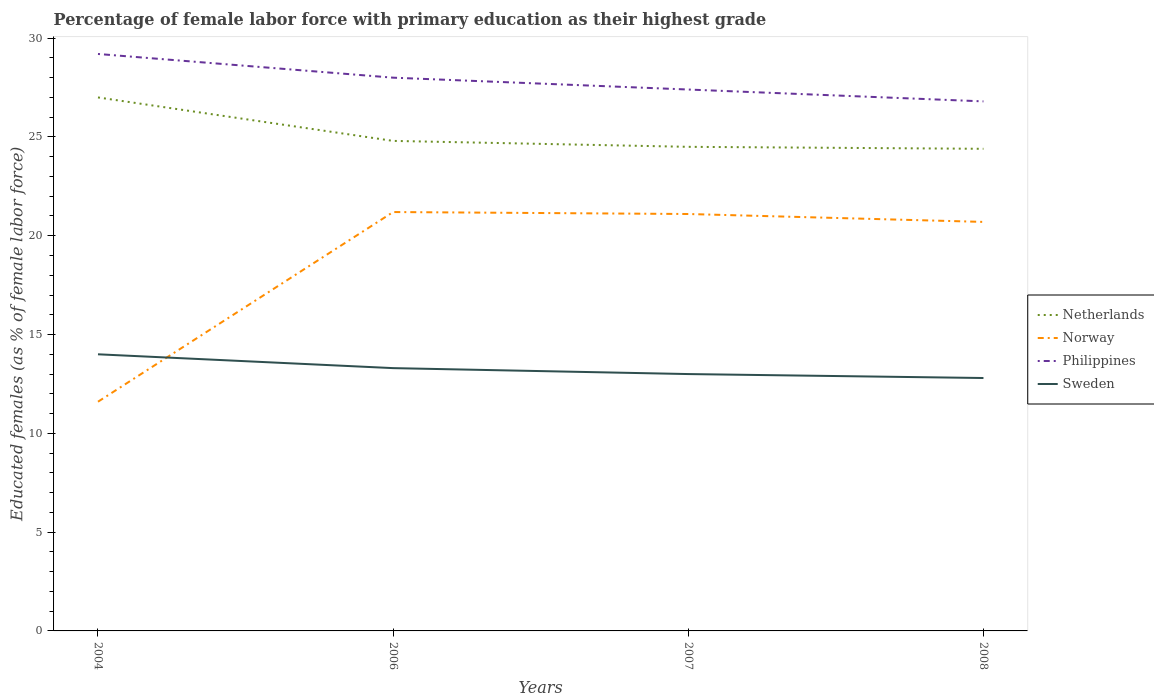Does the line corresponding to Philippines intersect with the line corresponding to Norway?
Offer a very short reply. No. Across all years, what is the maximum percentage of female labor force with primary education in Netherlands?
Provide a succinct answer. 24.4. What is the total percentage of female labor force with primary education in Netherlands in the graph?
Your response must be concise. 2.2. What is the difference between the highest and the second highest percentage of female labor force with primary education in Netherlands?
Offer a very short reply. 2.6. What is the difference between the highest and the lowest percentage of female labor force with primary education in Philippines?
Your answer should be compact. 2. What is the difference between two consecutive major ticks on the Y-axis?
Offer a very short reply. 5. Does the graph contain grids?
Make the answer very short. No. How many legend labels are there?
Your response must be concise. 4. What is the title of the graph?
Offer a very short reply. Percentage of female labor force with primary education as their highest grade. Does "Solomon Islands" appear as one of the legend labels in the graph?
Provide a succinct answer. No. What is the label or title of the Y-axis?
Make the answer very short. Educated females (as % of female labor force). What is the Educated females (as % of female labor force) of Norway in 2004?
Your answer should be compact. 11.6. What is the Educated females (as % of female labor force) in Philippines in 2004?
Offer a very short reply. 29.2. What is the Educated females (as % of female labor force) in Netherlands in 2006?
Offer a terse response. 24.8. What is the Educated females (as % of female labor force) in Norway in 2006?
Give a very brief answer. 21.2. What is the Educated females (as % of female labor force) of Sweden in 2006?
Keep it short and to the point. 13.3. What is the Educated females (as % of female labor force) in Netherlands in 2007?
Ensure brevity in your answer.  24.5. What is the Educated females (as % of female labor force) of Norway in 2007?
Provide a short and direct response. 21.1. What is the Educated females (as % of female labor force) of Philippines in 2007?
Your answer should be very brief. 27.4. What is the Educated females (as % of female labor force) of Sweden in 2007?
Your answer should be compact. 13. What is the Educated females (as % of female labor force) of Netherlands in 2008?
Provide a succinct answer. 24.4. What is the Educated females (as % of female labor force) of Norway in 2008?
Your response must be concise. 20.7. What is the Educated females (as % of female labor force) of Philippines in 2008?
Provide a succinct answer. 26.8. What is the Educated females (as % of female labor force) in Sweden in 2008?
Provide a succinct answer. 12.8. Across all years, what is the maximum Educated females (as % of female labor force) of Norway?
Offer a very short reply. 21.2. Across all years, what is the maximum Educated females (as % of female labor force) in Philippines?
Offer a terse response. 29.2. Across all years, what is the maximum Educated females (as % of female labor force) of Sweden?
Keep it short and to the point. 14. Across all years, what is the minimum Educated females (as % of female labor force) of Netherlands?
Keep it short and to the point. 24.4. Across all years, what is the minimum Educated females (as % of female labor force) of Norway?
Your answer should be very brief. 11.6. Across all years, what is the minimum Educated females (as % of female labor force) in Philippines?
Your response must be concise. 26.8. Across all years, what is the minimum Educated females (as % of female labor force) of Sweden?
Your response must be concise. 12.8. What is the total Educated females (as % of female labor force) of Netherlands in the graph?
Give a very brief answer. 100.7. What is the total Educated females (as % of female labor force) of Norway in the graph?
Your answer should be compact. 74.6. What is the total Educated females (as % of female labor force) in Philippines in the graph?
Provide a succinct answer. 111.4. What is the total Educated females (as % of female labor force) of Sweden in the graph?
Offer a terse response. 53.1. What is the difference between the Educated females (as % of female labor force) in Norway in 2004 and that in 2006?
Provide a succinct answer. -9.6. What is the difference between the Educated females (as % of female labor force) in Philippines in 2004 and that in 2006?
Ensure brevity in your answer.  1.2. What is the difference between the Educated females (as % of female labor force) of Norway in 2004 and that in 2007?
Give a very brief answer. -9.5. What is the difference between the Educated females (as % of female labor force) of Philippines in 2004 and that in 2007?
Your answer should be compact. 1.8. What is the difference between the Educated females (as % of female labor force) of Sweden in 2004 and that in 2007?
Make the answer very short. 1. What is the difference between the Educated females (as % of female labor force) of Netherlands in 2004 and that in 2008?
Your answer should be compact. 2.6. What is the difference between the Educated females (as % of female labor force) in Norway in 2004 and that in 2008?
Your answer should be compact. -9.1. What is the difference between the Educated females (as % of female labor force) of Netherlands in 2006 and that in 2007?
Give a very brief answer. 0.3. What is the difference between the Educated females (as % of female labor force) in Philippines in 2006 and that in 2007?
Your response must be concise. 0.6. What is the difference between the Educated females (as % of female labor force) of Sweden in 2006 and that in 2007?
Offer a very short reply. 0.3. What is the difference between the Educated females (as % of female labor force) in Sweden in 2006 and that in 2008?
Your answer should be very brief. 0.5. What is the difference between the Educated females (as % of female labor force) of Netherlands in 2007 and that in 2008?
Your response must be concise. 0.1. What is the difference between the Educated females (as % of female labor force) in Netherlands in 2004 and the Educated females (as % of female labor force) in Norway in 2006?
Provide a succinct answer. 5.8. What is the difference between the Educated females (as % of female labor force) of Netherlands in 2004 and the Educated females (as % of female labor force) of Philippines in 2006?
Offer a very short reply. -1. What is the difference between the Educated females (as % of female labor force) in Netherlands in 2004 and the Educated females (as % of female labor force) in Sweden in 2006?
Provide a short and direct response. 13.7. What is the difference between the Educated females (as % of female labor force) of Norway in 2004 and the Educated females (as % of female labor force) of Philippines in 2006?
Provide a short and direct response. -16.4. What is the difference between the Educated females (as % of female labor force) in Netherlands in 2004 and the Educated females (as % of female labor force) in Norway in 2007?
Keep it short and to the point. 5.9. What is the difference between the Educated females (as % of female labor force) of Netherlands in 2004 and the Educated females (as % of female labor force) of Philippines in 2007?
Make the answer very short. -0.4. What is the difference between the Educated females (as % of female labor force) in Netherlands in 2004 and the Educated females (as % of female labor force) in Sweden in 2007?
Make the answer very short. 14. What is the difference between the Educated females (as % of female labor force) in Norway in 2004 and the Educated females (as % of female labor force) in Philippines in 2007?
Your answer should be very brief. -15.8. What is the difference between the Educated females (as % of female labor force) in Norway in 2004 and the Educated females (as % of female labor force) in Sweden in 2007?
Your response must be concise. -1.4. What is the difference between the Educated females (as % of female labor force) of Netherlands in 2004 and the Educated females (as % of female labor force) of Philippines in 2008?
Provide a short and direct response. 0.2. What is the difference between the Educated females (as % of female labor force) in Norway in 2004 and the Educated females (as % of female labor force) in Philippines in 2008?
Provide a short and direct response. -15.2. What is the difference between the Educated females (as % of female labor force) in Netherlands in 2006 and the Educated females (as % of female labor force) in Philippines in 2007?
Ensure brevity in your answer.  -2.6. What is the difference between the Educated females (as % of female labor force) in Netherlands in 2006 and the Educated females (as % of female labor force) in Sweden in 2007?
Your answer should be very brief. 11.8. What is the difference between the Educated females (as % of female labor force) of Norway in 2006 and the Educated females (as % of female labor force) of Sweden in 2007?
Your response must be concise. 8.2. What is the difference between the Educated females (as % of female labor force) of Philippines in 2006 and the Educated females (as % of female labor force) of Sweden in 2007?
Ensure brevity in your answer.  15. What is the difference between the Educated females (as % of female labor force) in Netherlands in 2006 and the Educated females (as % of female labor force) in Philippines in 2008?
Make the answer very short. -2. What is the difference between the Educated females (as % of female labor force) in Norway in 2006 and the Educated females (as % of female labor force) in Philippines in 2008?
Offer a terse response. -5.6. What is the difference between the Educated females (as % of female labor force) of Norway in 2006 and the Educated females (as % of female labor force) of Sweden in 2008?
Your answer should be very brief. 8.4. What is the difference between the Educated females (as % of female labor force) in Netherlands in 2007 and the Educated females (as % of female labor force) in Norway in 2008?
Ensure brevity in your answer.  3.8. What is the difference between the Educated females (as % of female labor force) of Netherlands in 2007 and the Educated females (as % of female labor force) of Sweden in 2008?
Your answer should be compact. 11.7. What is the difference between the Educated females (as % of female labor force) of Norway in 2007 and the Educated females (as % of female labor force) of Philippines in 2008?
Your answer should be compact. -5.7. What is the difference between the Educated females (as % of female labor force) of Norway in 2007 and the Educated females (as % of female labor force) of Sweden in 2008?
Make the answer very short. 8.3. What is the average Educated females (as % of female labor force) in Netherlands per year?
Provide a succinct answer. 25.18. What is the average Educated females (as % of female labor force) in Norway per year?
Keep it short and to the point. 18.65. What is the average Educated females (as % of female labor force) in Philippines per year?
Offer a terse response. 27.85. What is the average Educated females (as % of female labor force) of Sweden per year?
Keep it short and to the point. 13.28. In the year 2004, what is the difference between the Educated females (as % of female labor force) of Netherlands and Educated females (as % of female labor force) of Norway?
Your answer should be very brief. 15.4. In the year 2004, what is the difference between the Educated females (as % of female labor force) in Netherlands and Educated females (as % of female labor force) in Philippines?
Ensure brevity in your answer.  -2.2. In the year 2004, what is the difference between the Educated females (as % of female labor force) in Norway and Educated females (as % of female labor force) in Philippines?
Give a very brief answer. -17.6. In the year 2004, what is the difference between the Educated females (as % of female labor force) in Norway and Educated females (as % of female labor force) in Sweden?
Ensure brevity in your answer.  -2.4. In the year 2006, what is the difference between the Educated females (as % of female labor force) in Netherlands and Educated females (as % of female labor force) in Philippines?
Your answer should be very brief. -3.2. In the year 2006, what is the difference between the Educated females (as % of female labor force) in Netherlands and Educated females (as % of female labor force) in Sweden?
Your response must be concise. 11.5. In the year 2007, what is the difference between the Educated females (as % of female labor force) of Netherlands and Educated females (as % of female labor force) of Norway?
Your answer should be very brief. 3.4. In the year 2007, what is the difference between the Educated females (as % of female labor force) in Netherlands and Educated females (as % of female labor force) in Philippines?
Give a very brief answer. -2.9. In the year 2007, what is the difference between the Educated females (as % of female labor force) of Netherlands and Educated females (as % of female labor force) of Sweden?
Provide a short and direct response. 11.5. In the year 2008, what is the difference between the Educated females (as % of female labor force) of Netherlands and Educated females (as % of female labor force) of Norway?
Your answer should be compact. 3.7. In the year 2008, what is the difference between the Educated females (as % of female labor force) of Norway and Educated females (as % of female labor force) of Sweden?
Give a very brief answer. 7.9. In the year 2008, what is the difference between the Educated females (as % of female labor force) of Philippines and Educated females (as % of female labor force) of Sweden?
Your response must be concise. 14. What is the ratio of the Educated females (as % of female labor force) in Netherlands in 2004 to that in 2006?
Keep it short and to the point. 1.09. What is the ratio of the Educated females (as % of female labor force) of Norway in 2004 to that in 2006?
Your answer should be very brief. 0.55. What is the ratio of the Educated females (as % of female labor force) of Philippines in 2004 to that in 2006?
Keep it short and to the point. 1.04. What is the ratio of the Educated females (as % of female labor force) in Sweden in 2004 to that in 2006?
Give a very brief answer. 1.05. What is the ratio of the Educated females (as % of female labor force) of Netherlands in 2004 to that in 2007?
Provide a succinct answer. 1.1. What is the ratio of the Educated females (as % of female labor force) in Norway in 2004 to that in 2007?
Your answer should be compact. 0.55. What is the ratio of the Educated females (as % of female labor force) of Philippines in 2004 to that in 2007?
Offer a very short reply. 1.07. What is the ratio of the Educated females (as % of female labor force) of Sweden in 2004 to that in 2007?
Offer a terse response. 1.08. What is the ratio of the Educated females (as % of female labor force) of Netherlands in 2004 to that in 2008?
Keep it short and to the point. 1.11. What is the ratio of the Educated females (as % of female labor force) of Norway in 2004 to that in 2008?
Ensure brevity in your answer.  0.56. What is the ratio of the Educated females (as % of female labor force) in Philippines in 2004 to that in 2008?
Make the answer very short. 1.09. What is the ratio of the Educated females (as % of female labor force) of Sweden in 2004 to that in 2008?
Your answer should be very brief. 1.09. What is the ratio of the Educated females (as % of female labor force) in Netherlands in 2006 to that in 2007?
Make the answer very short. 1.01. What is the ratio of the Educated females (as % of female labor force) in Philippines in 2006 to that in 2007?
Your answer should be very brief. 1.02. What is the ratio of the Educated females (as % of female labor force) of Sweden in 2006 to that in 2007?
Ensure brevity in your answer.  1.02. What is the ratio of the Educated females (as % of female labor force) of Netherlands in 2006 to that in 2008?
Offer a terse response. 1.02. What is the ratio of the Educated females (as % of female labor force) in Norway in 2006 to that in 2008?
Ensure brevity in your answer.  1.02. What is the ratio of the Educated females (as % of female labor force) of Philippines in 2006 to that in 2008?
Give a very brief answer. 1.04. What is the ratio of the Educated females (as % of female labor force) in Sweden in 2006 to that in 2008?
Provide a succinct answer. 1.04. What is the ratio of the Educated females (as % of female labor force) in Norway in 2007 to that in 2008?
Ensure brevity in your answer.  1.02. What is the ratio of the Educated females (as % of female labor force) of Philippines in 2007 to that in 2008?
Make the answer very short. 1.02. What is the ratio of the Educated females (as % of female labor force) in Sweden in 2007 to that in 2008?
Your answer should be very brief. 1.02. What is the difference between the highest and the second highest Educated females (as % of female labor force) of Netherlands?
Keep it short and to the point. 2.2. What is the difference between the highest and the second highest Educated females (as % of female labor force) of Norway?
Your response must be concise. 0.1. What is the difference between the highest and the second highest Educated females (as % of female labor force) in Philippines?
Keep it short and to the point. 1.2. What is the difference between the highest and the lowest Educated females (as % of female labor force) in Philippines?
Make the answer very short. 2.4. What is the difference between the highest and the lowest Educated females (as % of female labor force) in Sweden?
Your response must be concise. 1.2. 